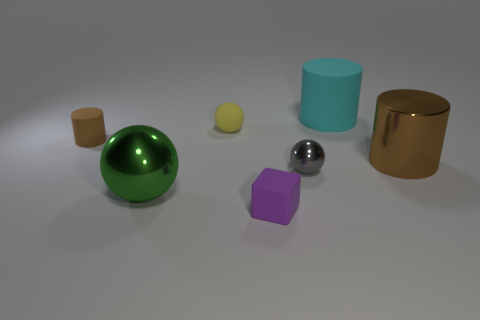Add 3 gray objects. How many objects exist? 10 Subtract all cubes. How many objects are left? 6 Subtract 1 purple cubes. How many objects are left? 6 Subtract all large yellow things. Subtract all purple objects. How many objects are left? 6 Add 6 purple matte things. How many purple matte things are left? 7 Add 2 big red blocks. How many big red blocks exist? 2 